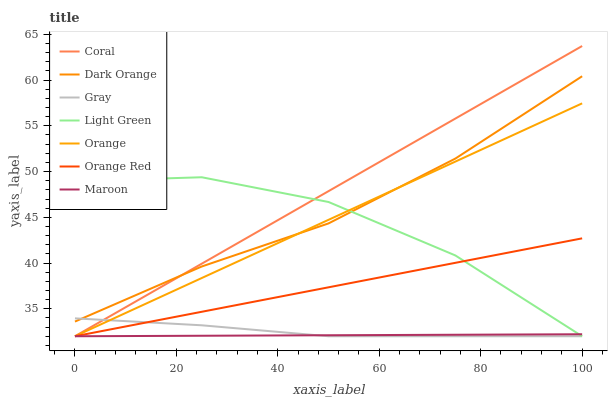Does Gray have the minimum area under the curve?
Answer yes or no. No. Does Gray have the maximum area under the curve?
Answer yes or no. No. Is Gray the smoothest?
Answer yes or no. No. Is Gray the roughest?
Answer yes or no. No. Does Gray have the highest value?
Answer yes or no. No. Is Orange Red less than Dark Orange?
Answer yes or no. Yes. Is Dark Orange greater than Maroon?
Answer yes or no. Yes. Does Orange Red intersect Dark Orange?
Answer yes or no. No. 